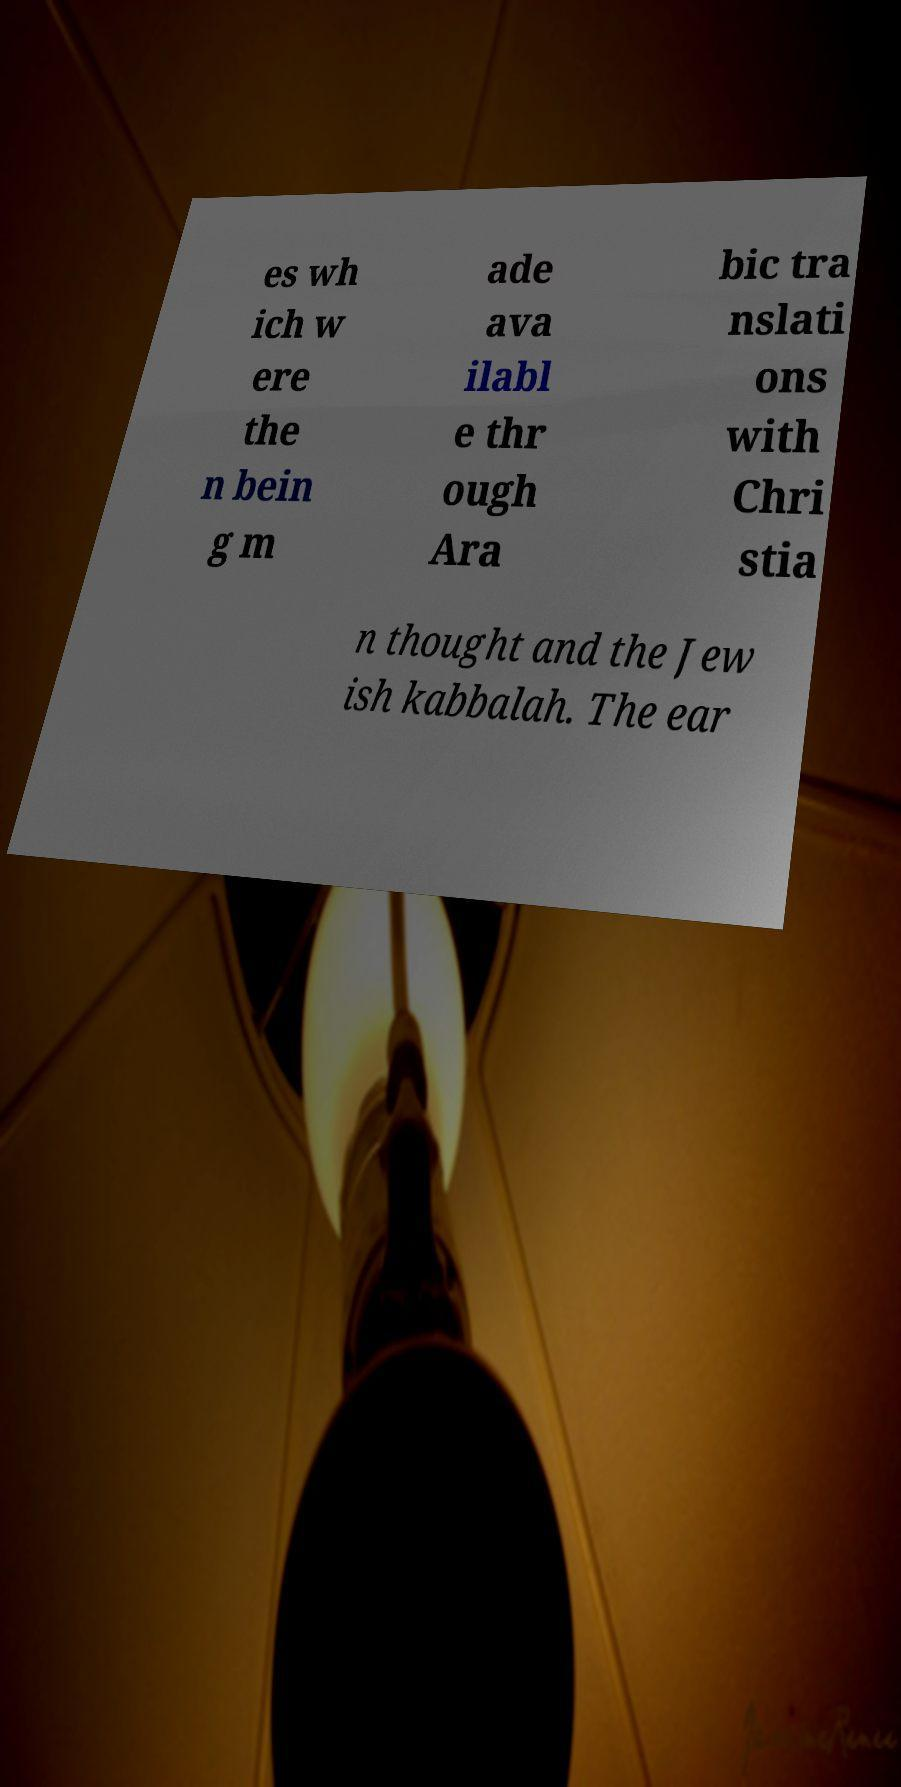I need the written content from this picture converted into text. Can you do that? es wh ich w ere the n bein g m ade ava ilabl e thr ough Ara bic tra nslati ons with Chri stia n thought and the Jew ish kabbalah. The ear 